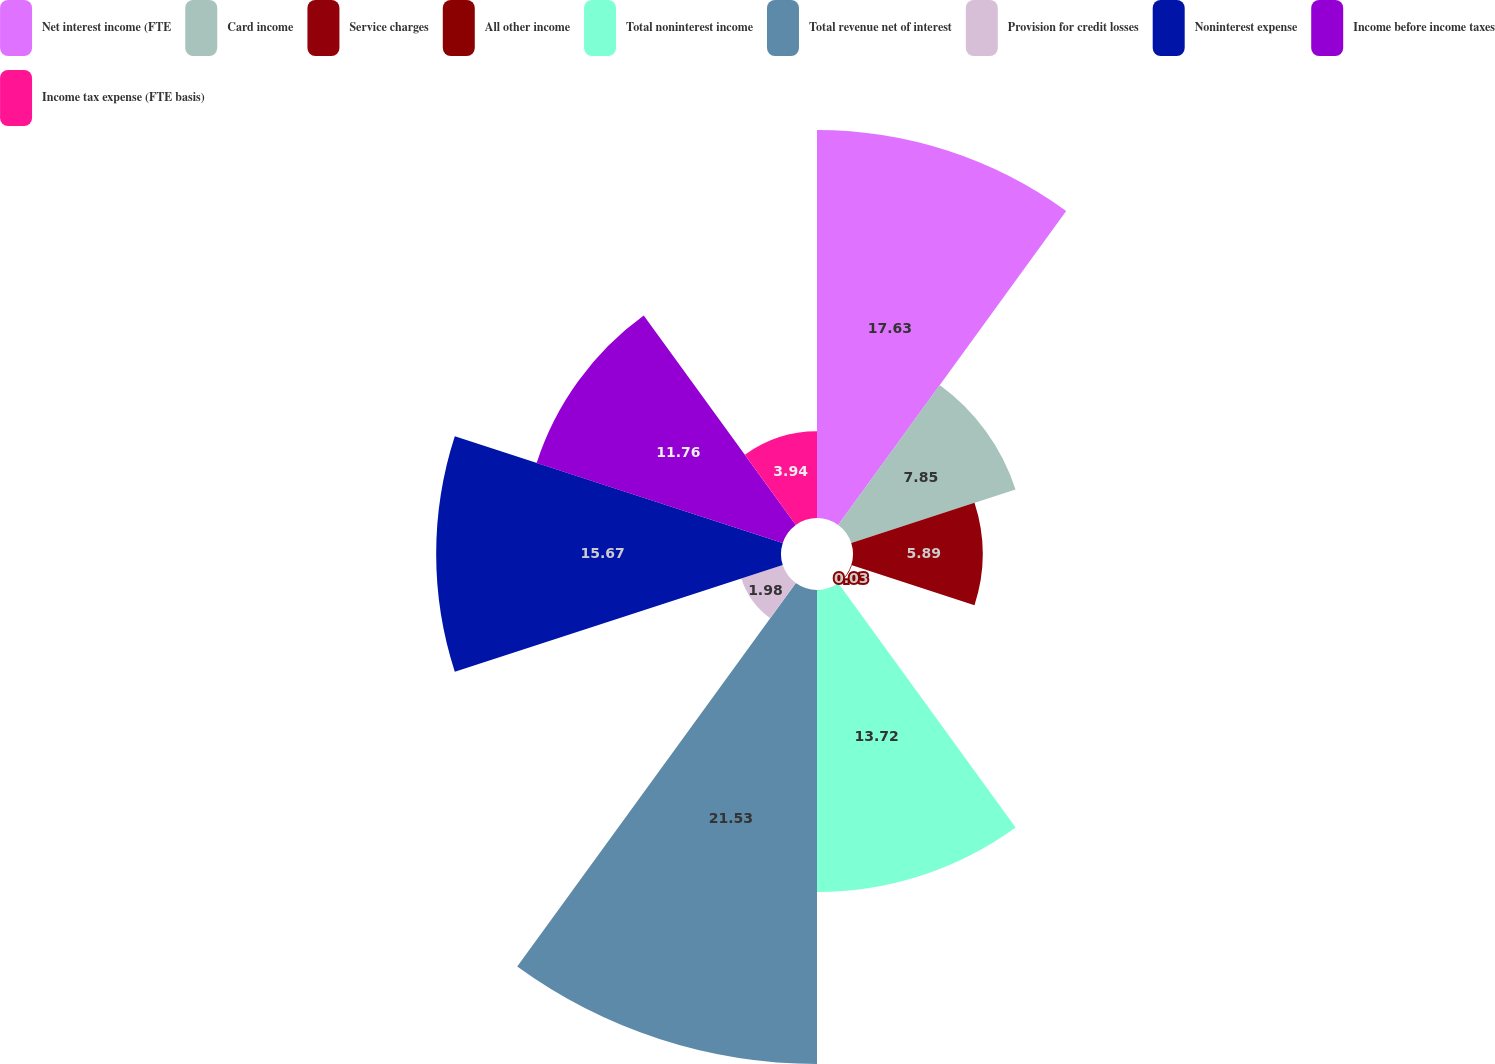Convert chart to OTSL. <chart><loc_0><loc_0><loc_500><loc_500><pie_chart><fcel>Net interest income (FTE<fcel>Card income<fcel>Service charges<fcel>All other income<fcel>Total noninterest income<fcel>Total revenue net of interest<fcel>Provision for credit losses<fcel>Noninterest expense<fcel>Income before income taxes<fcel>Income tax expense (FTE basis)<nl><fcel>17.63%<fcel>7.85%<fcel>5.89%<fcel>0.03%<fcel>13.72%<fcel>21.54%<fcel>1.98%<fcel>15.67%<fcel>11.76%<fcel>3.94%<nl></chart> 